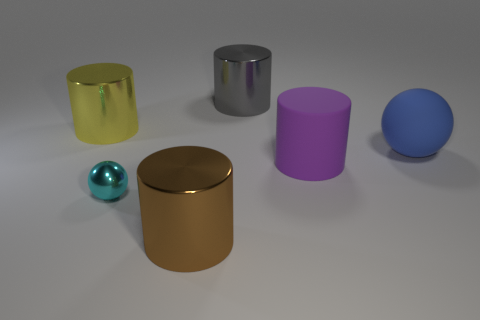How many small things are either red things or brown metallic cylinders?
Your response must be concise. 0. What shape is the large metal object in front of the cyan sphere?
Your response must be concise. Cylinder. Is there a small shiny sphere that has the same color as the big ball?
Your answer should be very brief. No. There is a purple rubber cylinder behind the cyan object; does it have the same size as the metal cylinder in front of the big purple rubber cylinder?
Your answer should be compact. Yes. Is the number of large cylinders to the left of the blue rubber thing greater than the number of big yellow shiny cylinders that are on the left side of the big gray metal cylinder?
Your answer should be very brief. Yes. Are there any tiny cyan objects that have the same material as the big blue object?
Make the answer very short. No. Does the big rubber sphere have the same color as the small thing?
Ensure brevity in your answer.  No. There is a large object that is both behind the big blue sphere and to the right of the cyan sphere; what is it made of?
Give a very brief answer. Metal. The tiny metal sphere has what color?
Provide a short and direct response. Cyan. How many tiny cyan objects have the same shape as the large yellow object?
Provide a short and direct response. 0. 